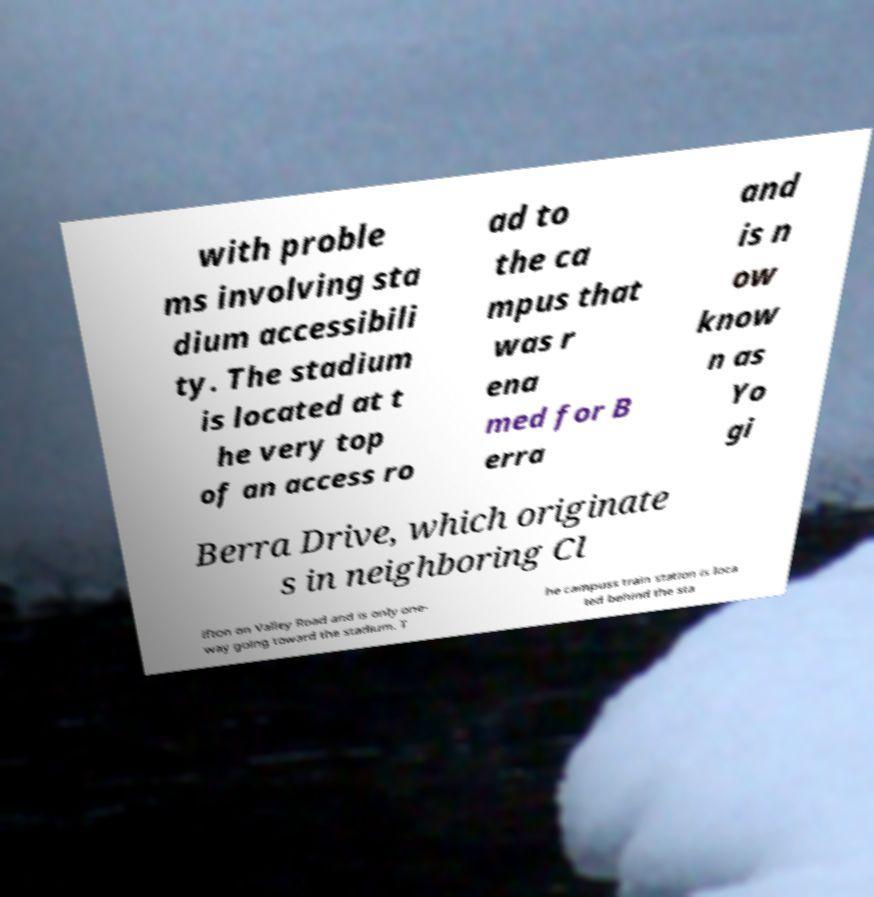There's text embedded in this image that I need extracted. Can you transcribe it verbatim? with proble ms involving sta dium accessibili ty. The stadium is located at t he very top of an access ro ad to the ca mpus that was r ena med for B erra and is n ow know n as Yo gi Berra Drive, which originate s in neighboring Cl ifton on Valley Road and is only one- way going toward the stadium. T he campuss train station is loca ted behind the sta 